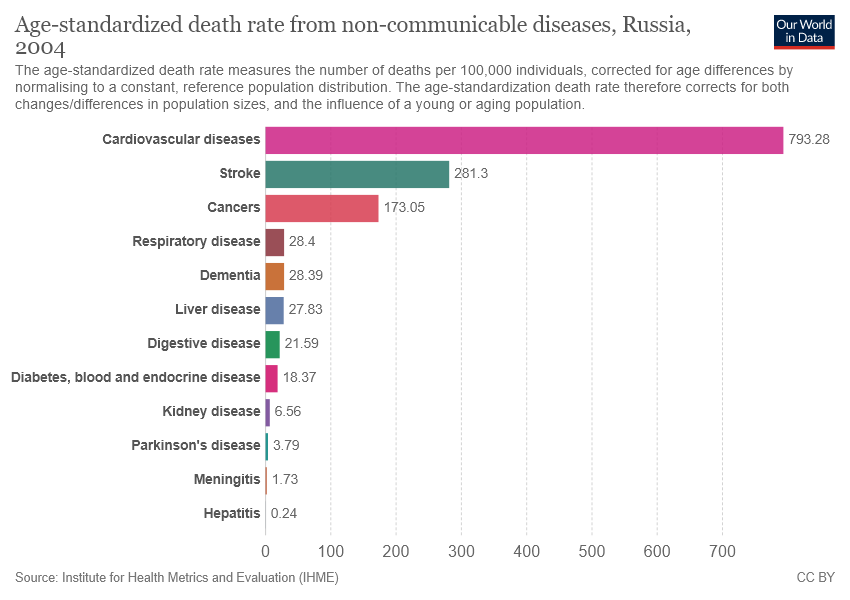Highlight a few significant elements in this photo. The bar graph shows 12 non-communicable diseases. 